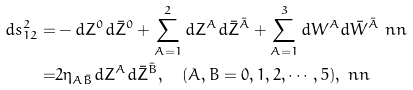Convert formula to latex. <formula><loc_0><loc_0><loc_500><loc_500>d s ^ { 2 } _ { 1 2 } = & - d Z ^ { 0 } d \bar { Z } ^ { 0 } + \sum _ { A = 1 } ^ { 2 } d Z ^ { A } d \bar { Z } ^ { \bar { A } } + \sum _ { A = 1 } ^ { 3 } d W ^ { A } d \bar { W } ^ { \bar { A } } \ n n \\ = & 2 \eta _ { A \bar { B } } d Z ^ { A } d \bar { Z } ^ { \bar { B } } , \quad ( A , B = 0 , 1 , 2 , \cdots , 5 ) , \ n n</formula> 